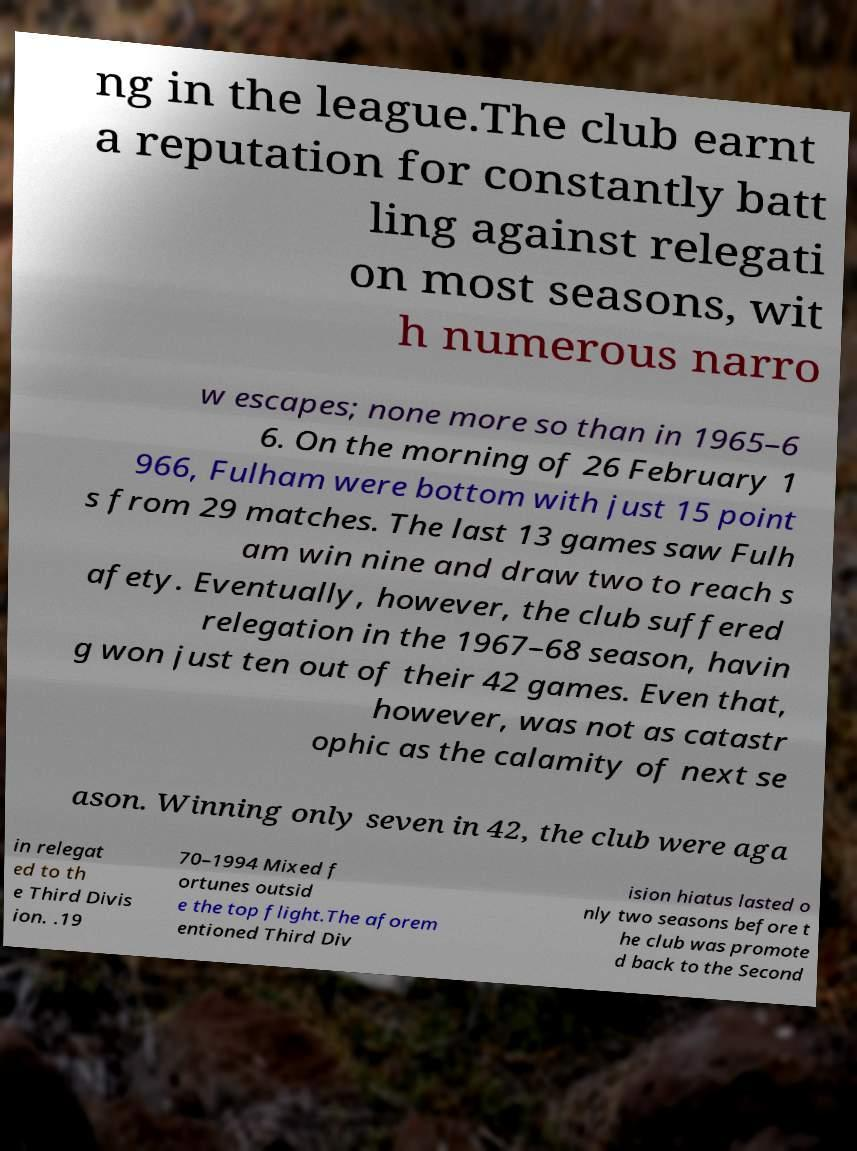I need the written content from this picture converted into text. Can you do that? ng in the league.The club earnt a reputation for constantly batt ling against relegati on most seasons, wit h numerous narro w escapes; none more so than in 1965–6 6. On the morning of 26 February 1 966, Fulham were bottom with just 15 point s from 29 matches. The last 13 games saw Fulh am win nine and draw two to reach s afety. Eventually, however, the club suffered relegation in the 1967–68 season, havin g won just ten out of their 42 games. Even that, however, was not as catastr ophic as the calamity of next se ason. Winning only seven in 42, the club were aga in relegat ed to th e Third Divis ion. .19 70–1994 Mixed f ortunes outsid e the top flight.The aforem entioned Third Div ision hiatus lasted o nly two seasons before t he club was promote d back to the Second 